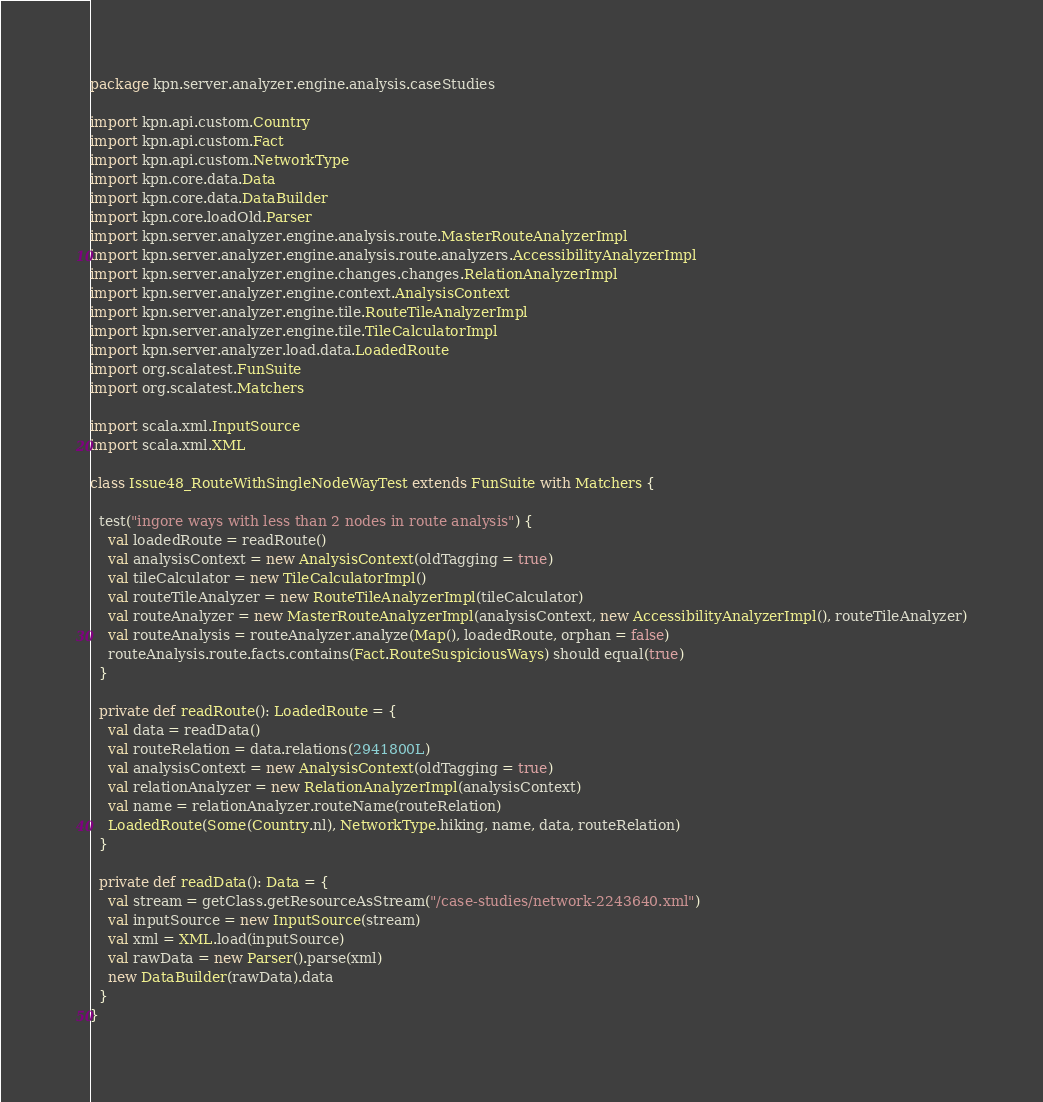Convert code to text. <code><loc_0><loc_0><loc_500><loc_500><_Scala_>package kpn.server.analyzer.engine.analysis.caseStudies

import kpn.api.custom.Country
import kpn.api.custom.Fact
import kpn.api.custom.NetworkType
import kpn.core.data.Data
import kpn.core.data.DataBuilder
import kpn.core.loadOld.Parser
import kpn.server.analyzer.engine.analysis.route.MasterRouteAnalyzerImpl
import kpn.server.analyzer.engine.analysis.route.analyzers.AccessibilityAnalyzerImpl
import kpn.server.analyzer.engine.changes.changes.RelationAnalyzerImpl
import kpn.server.analyzer.engine.context.AnalysisContext
import kpn.server.analyzer.engine.tile.RouteTileAnalyzerImpl
import kpn.server.analyzer.engine.tile.TileCalculatorImpl
import kpn.server.analyzer.load.data.LoadedRoute
import org.scalatest.FunSuite
import org.scalatest.Matchers

import scala.xml.InputSource
import scala.xml.XML

class Issue48_RouteWithSingleNodeWayTest extends FunSuite with Matchers {

  test("ingore ways with less than 2 nodes in route analysis") {
    val loadedRoute = readRoute()
    val analysisContext = new AnalysisContext(oldTagging = true)
    val tileCalculator = new TileCalculatorImpl()
    val routeTileAnalyzer = new RouteTileAnalyzerImpl(tileCalculator)
    val routeAnalyzer = new MasterRouteAnalyzerImpl(analysisContext, new AccessibilityAnalyzerImpl(), routeTileAnalyzer)
    val routeAnalysis = routeAnalyzer.analyze(Map(), loadedRoute, orphan = false)
    routeAnalysis.route.facts.contains(Fact.RouteSuspiciousWays) should equal(true)
  }

  private def readRoute(): LoadedRoute = {
    val data = readData()
    val routeRelation = data.relations(2941800L)
    val analysisContext = new AnalysisContext(oldTagging = true)
    val relationAnalyzer = new RelationAnalyzerImpl(analysisContext)
    val name = relationAnalyzer.routeName(routeRelation)
    LoadedRoute(Some(Country.nl), NetworkType.hiking, name, data, routeRelation)
  }

  private def readData(): Data = {
    val stream = getClass.getResourceAsStream("/case-studies/network-2243640.xml")
    val inputSource = new InputSource(stream)
    val xml = XML.load(inputSource)
    val rawData = new Parser().parse(xml)
    new DataBuilder(rawData).data
  }
}
</code> 